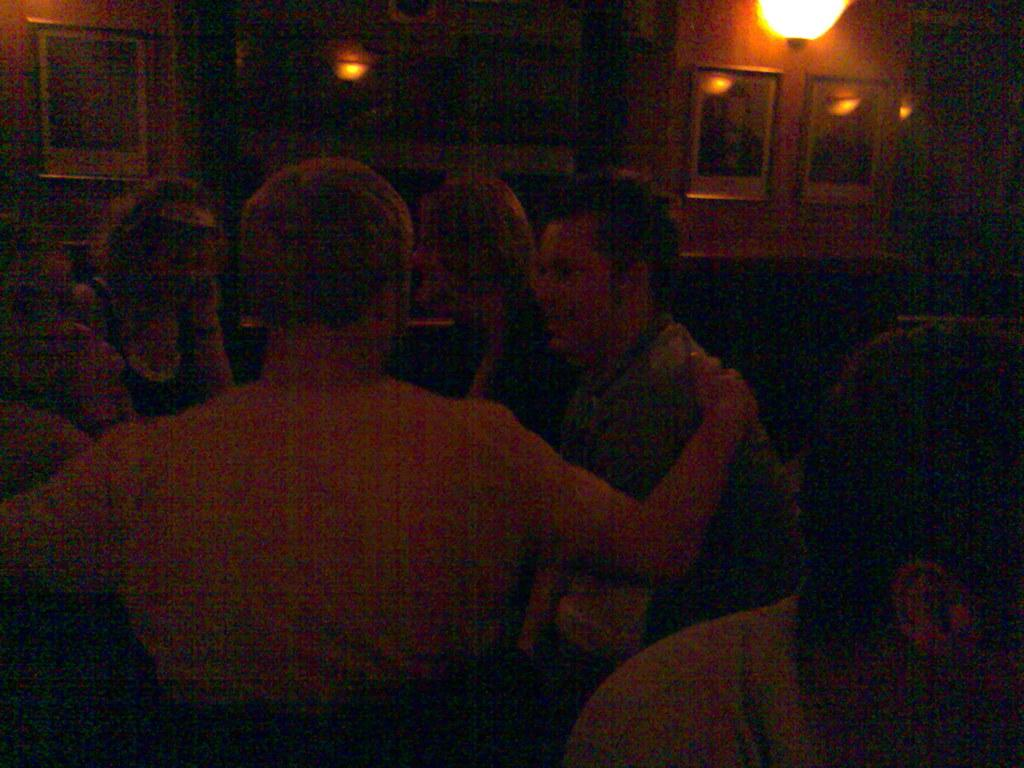What are the people in the image doing? The people in the image are sitting. What can be seen on the wall in the background? There are photo frames on the wall in the background. What is the source of light at the top of the image? There is a light at the top of the image. Who is the coach of the team in the image? There is no team or coach present in the image; it only shows people sitting and photo frames on the wall. 